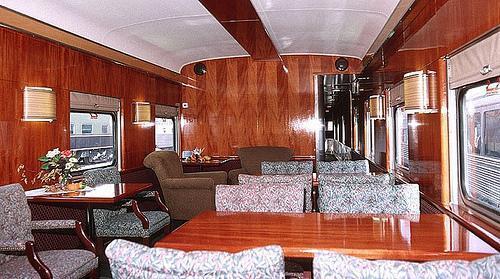How many people can have a seat?
Give a very brief answer. 12. How many dining tables are there?
Give a very brief answer. 2. How many chairs are there?
Give a very brief answer. 7. 